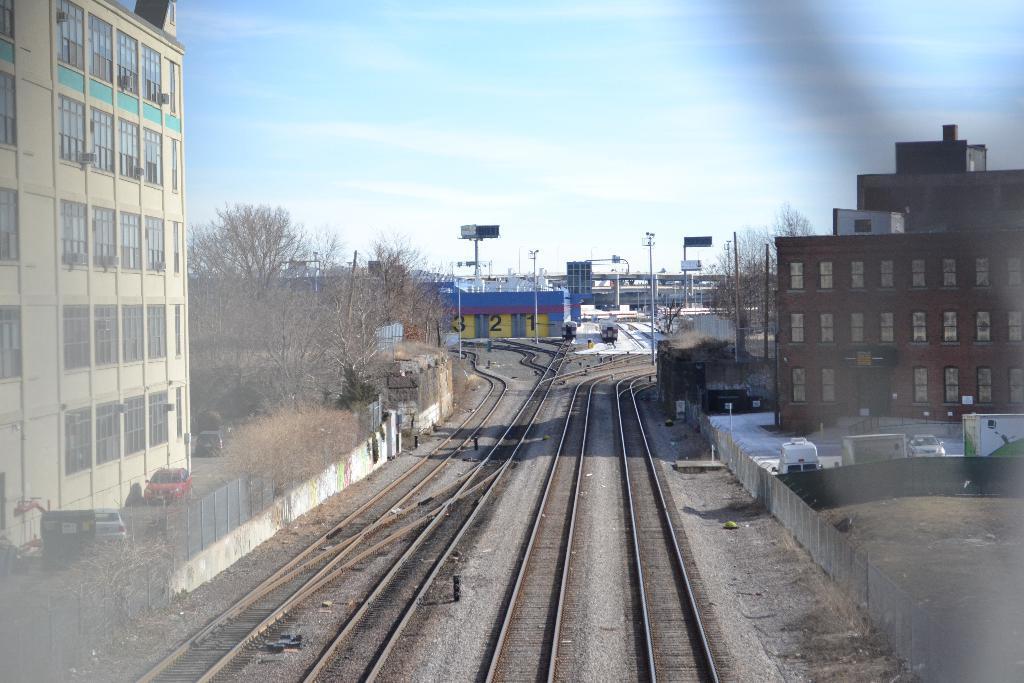Can you describe this image briefly? As we can see in the image there is a railway track, vehicles, fence, buildings, trees and at the top there is sky. 